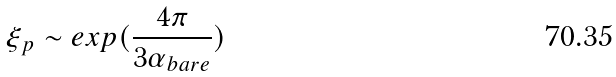Convert formula to latex. <formula><loc_0><loc_0><loc_500><loc_500>\xi _ { p } \sim e x p ( \frac { 4 \pi } { 3 \alpha _ { b a r e } } )</formula> 